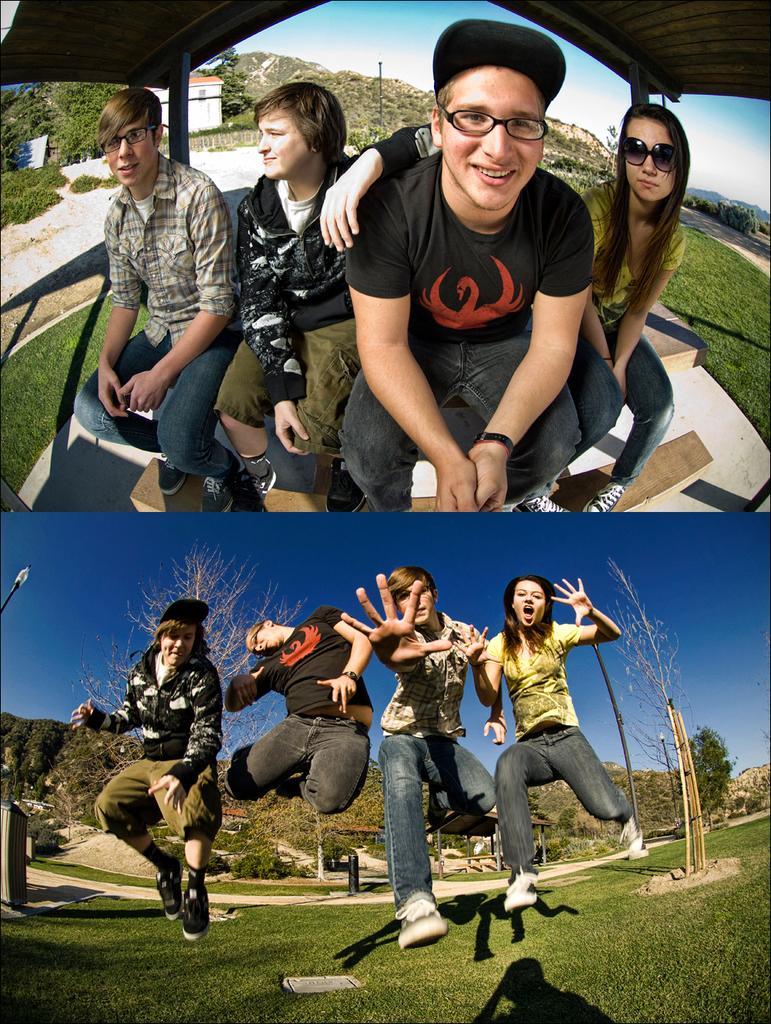How would you summarize this image in a sentence or two? In the image there is a collage. At the top of the image there are four people sitting on the wooden bench. On the right side of the image there is a lady with goggles. And there are two men with spectacles. There is a man with a cap on his head. On top of them there is a roof. Behind them there is a hill with trees and also there is a house. At the bottom of the image there on the ground there is grass. There are four people jumping. Behind them in the background there is a hill with trees. 